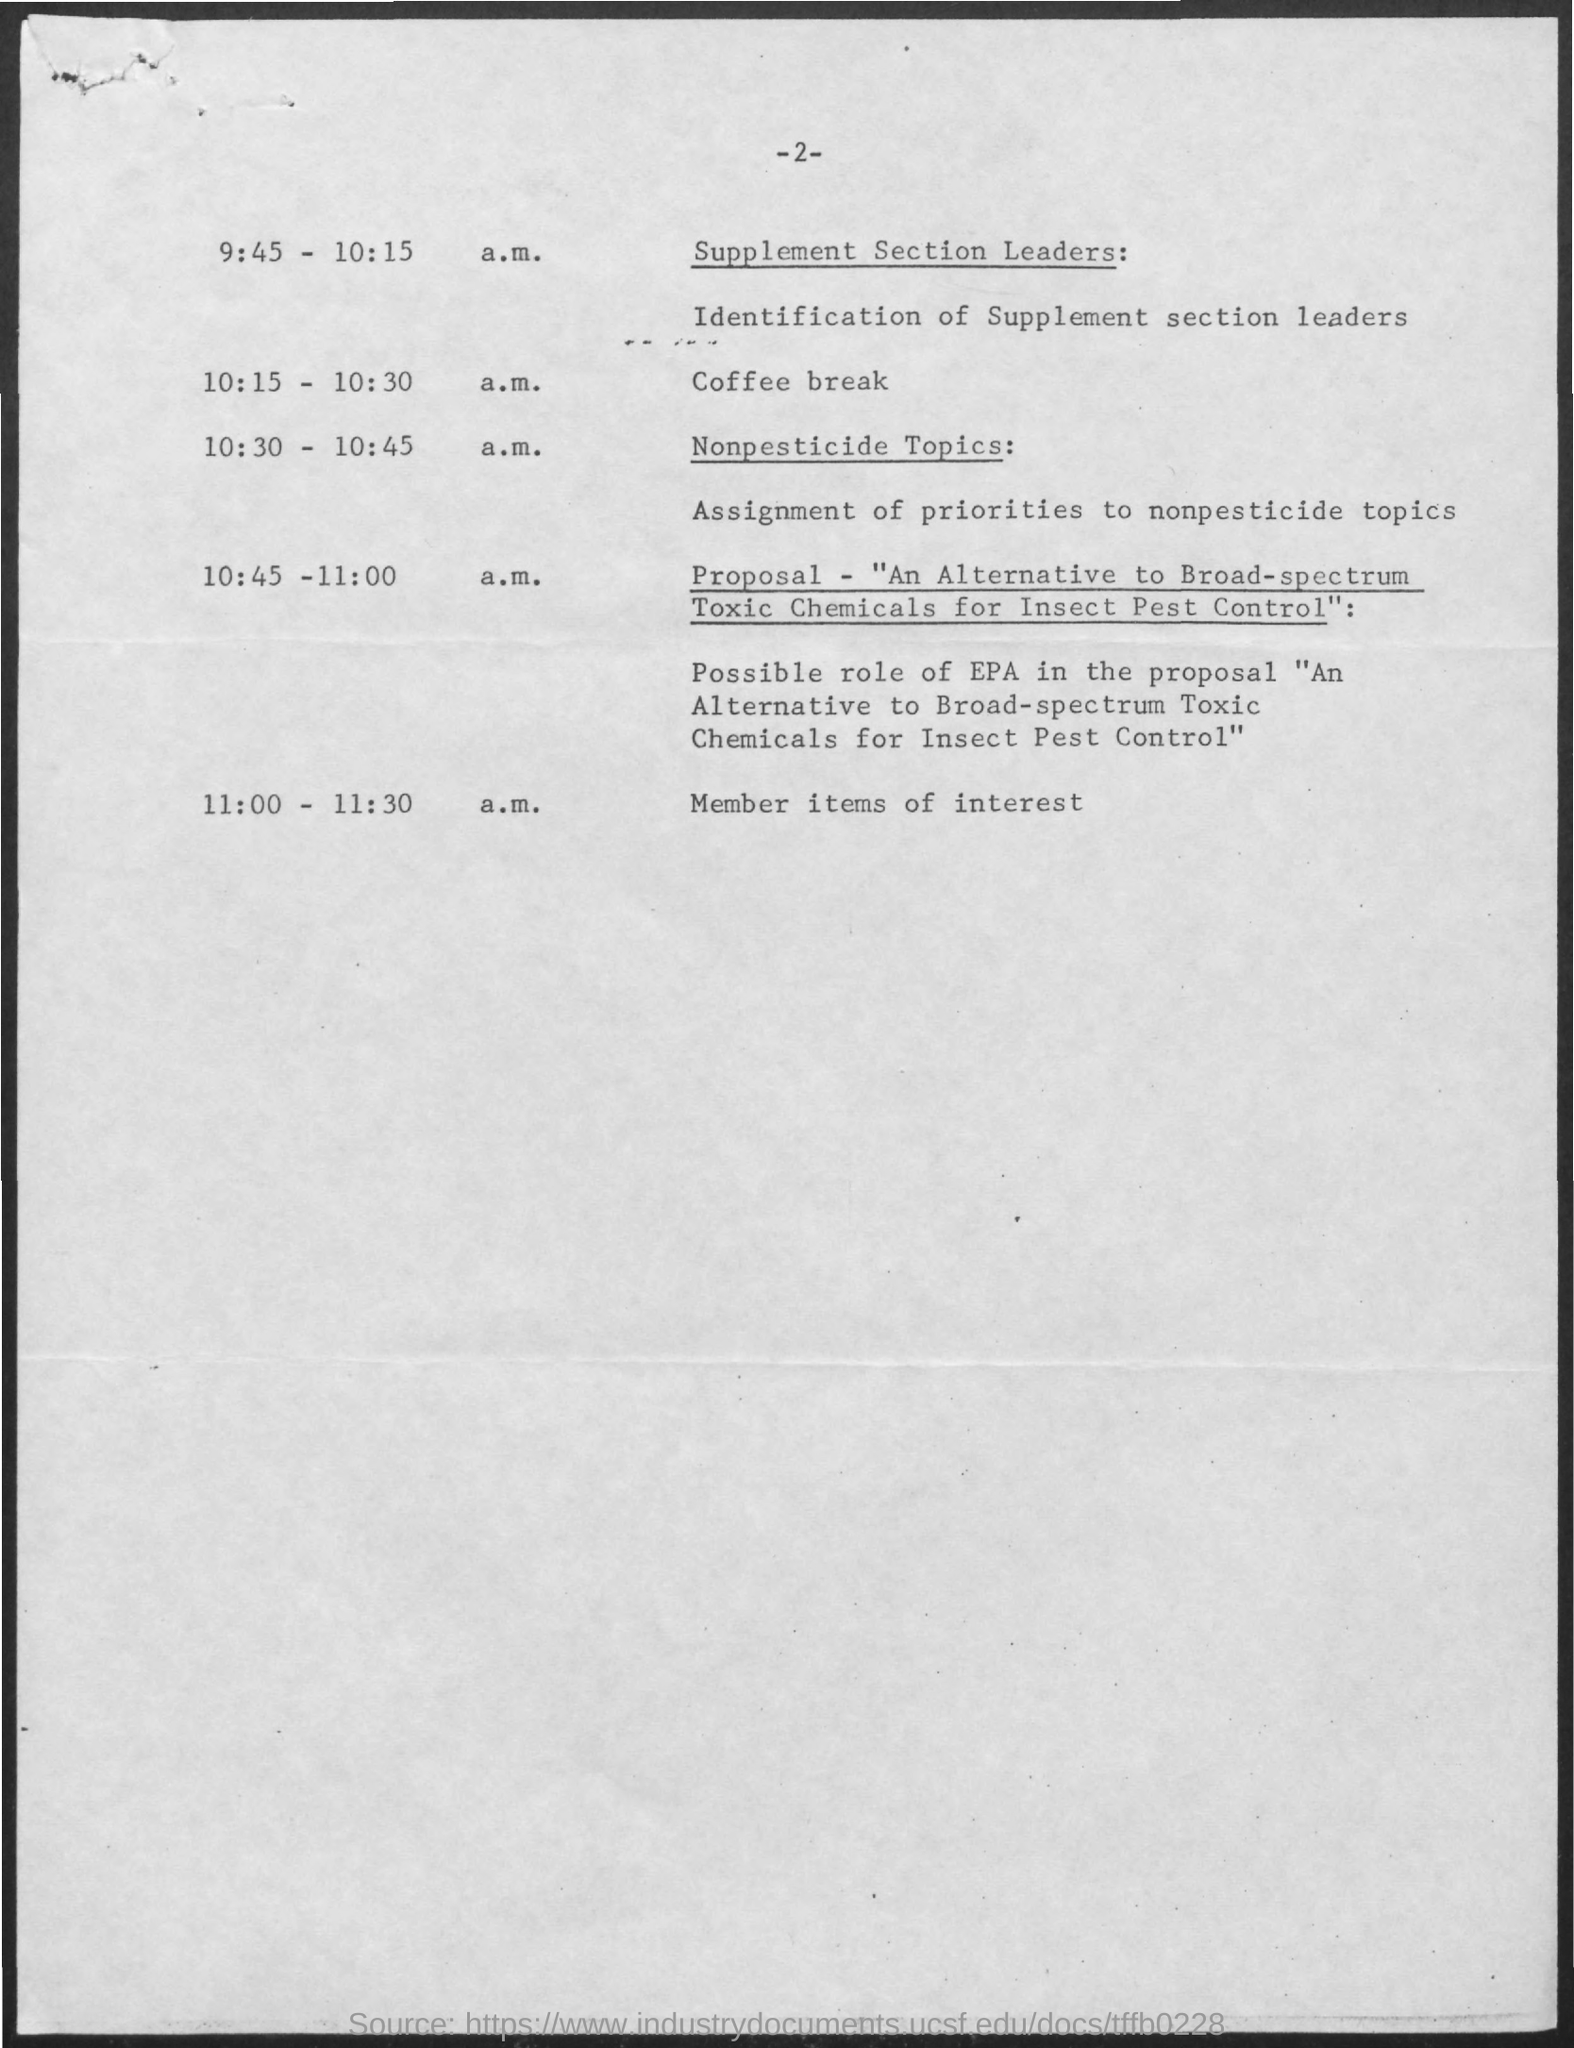When is the Coffee Break?
Offer a very short reply. 10:15 - 10:30 a.m. What is the item  under  "Supplement Section Leaders"?
Provide a short and direct response. Identification of Supplement  section Leaders. When is the Nonpesticide Topics?
Offer a terse response. 10:30 - 10:45 a.m. What is the Nonpesticide topic about?
Provide a short and direct response. Assignment of priorities to nonpesticide topics. What is the proposal about?
Provide a short and direct response. An Alternative to Broad-spectrum Toxic Chemicals for Insect Pest Control. What is the proposal time?
Make the answer very short. 10:45 -11:00 A.M. What is the program between 11:00 -11:30 a.m.?
Give a very brief answer. MEMBER ITEMS OF INTEREST. 